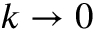<formula> <loc_0><loc_0><loc_500><loc_500>k \to 0</formula> 